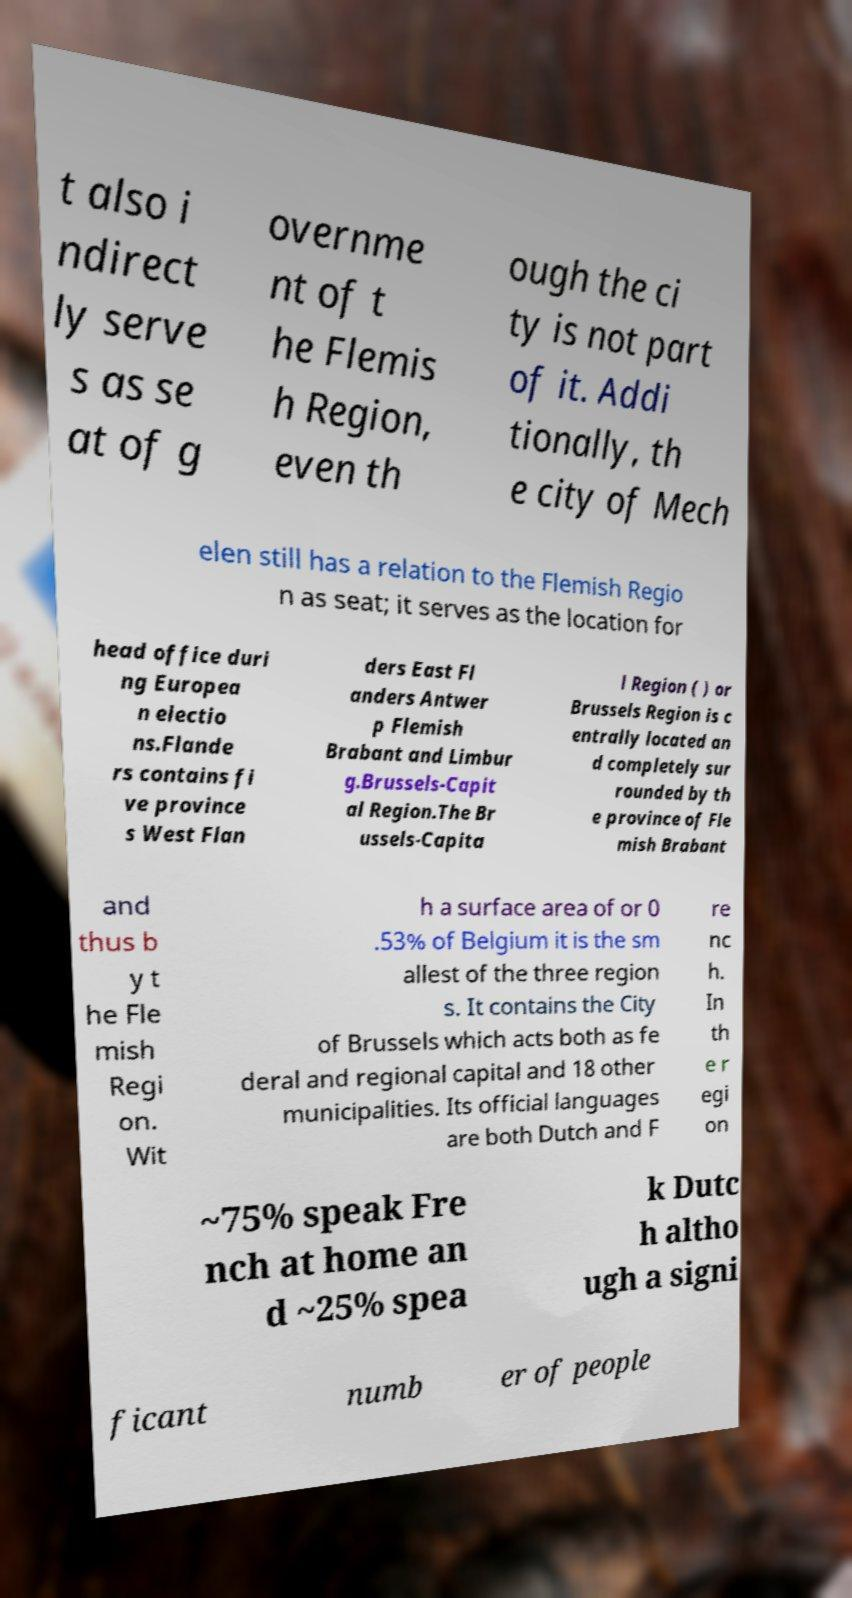Please read and relay the text visible in this image. What does it say? t also i ndirect ly serve s as se at of g overnme nt of t he Flemis h Region, even th ough the ci ty is not part of it. Addi tionally, th e city of Mech elen still has a relation to the Flemish Regio n as seat; it serves as the location for head office duri ng Europea n electio ns.Flande rs contains fi ve province s West Flan ders East Fl anders Antwer p Flemish Brabant and Limbur g.Brussels-Capit al Region.The Br ussels-Capita l Region ( ) or Brussels Region is c entrally located an d completely sur rounded by th e province of Fle mish Brabant and thus b y t he Fle mish Regi on. Wit h a surface area of or 0 .53% of Belgium it is the sm allest of the three region s. It contains the City of Brussels which acts both as fe deral and regional capital and 18 other municipalities. Its official languages are both Dutch and F re nc h. In th e r egi on ~75% speak Fre nch at home an d ~25% spea k Dutc h altho ugh a signi ficant numb er of people 